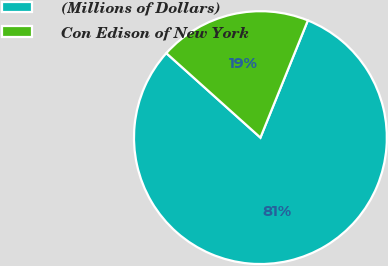<chart> <loc_0><loc_0><loc_500><loc_500><pie_chart><fcel>(Millions of Dollars)<fcel>Con Edison of New York<nl><fcel>80.52%<fcel>19.48%<nl></chart> 